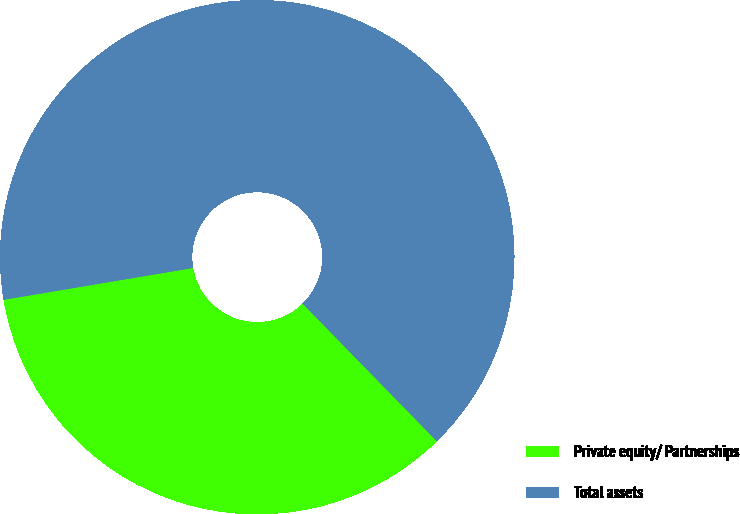Convert chart to OTSL. <chart><loc_0><loc_0><loc_500><loc_500><pie_chart><fcel>Private equity/ Partnerships<fcel>Total assets<nl><fcel>34.65%<fcel>65.35%<nl></chart> 